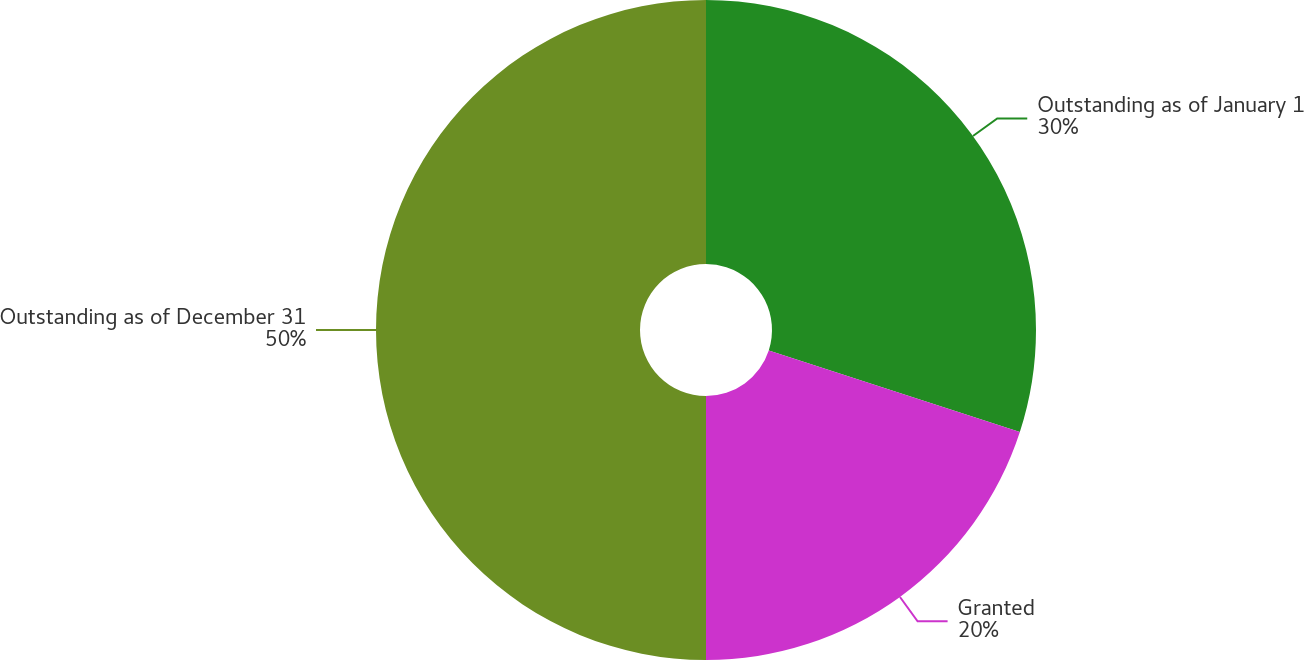Convert chart. <chart><loc_0><loc_0><loc_500><loc_500><pie_chart><fcel>Outstanding as of January 1<fcel>Granted<fcel>Outstanding as of December 31<nl><fcel>30.0%<fcel>20.0%<fcel>50.0%<nl></chart> 